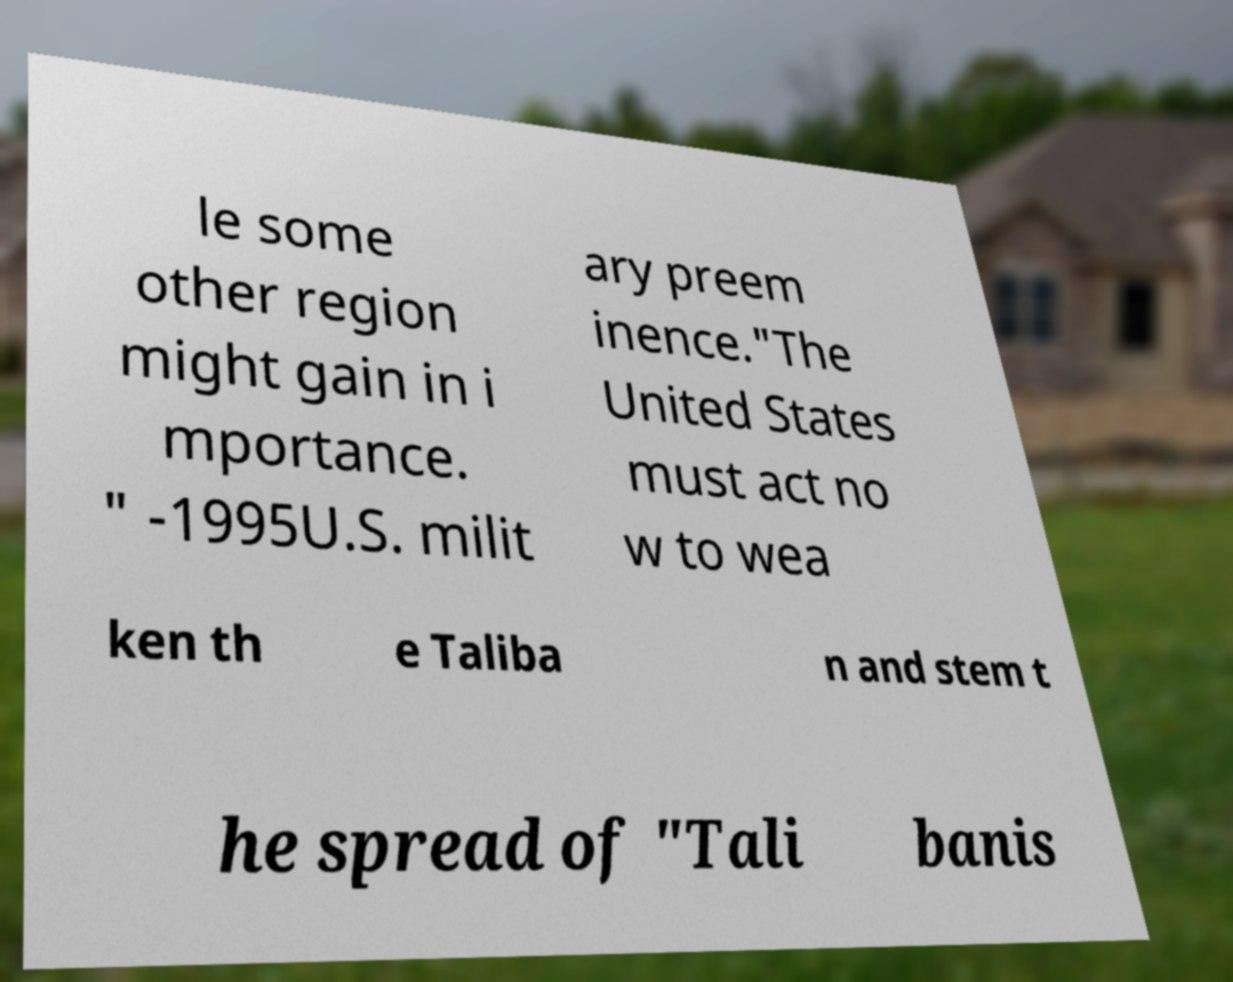Can you read and provide the text displayed in the image?This photo seems to have some interesting text. Can you extract and type it out for me? le some other region might gain in i mportance. " -1995U.S. milit ary preem inence."The United States must act no w to wea ken th e Taliba n and stem t he spread of "Tali banis 